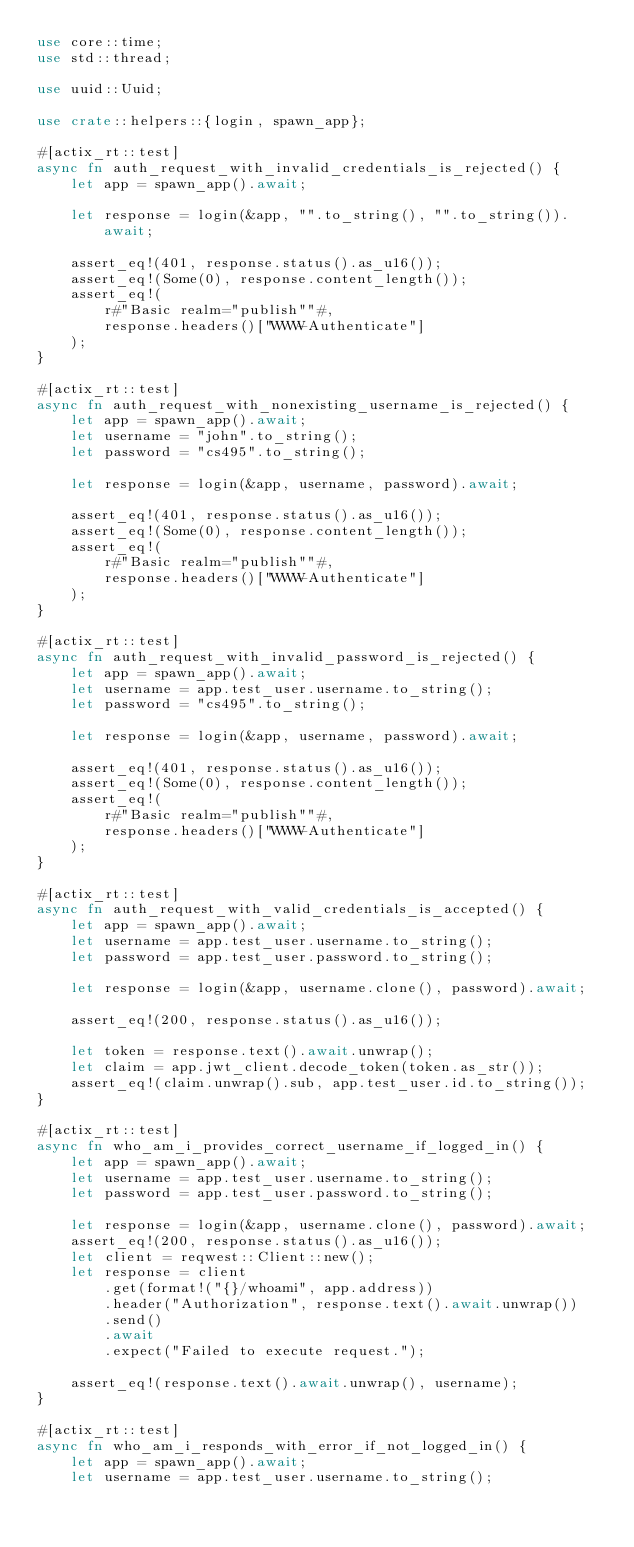Convert code to text. <code><loc_0><loc_0><loc_500><loc_500><_Rust_>use core::time;
use std::thread;

use uuid::Uuid;

use crate::helpers::{login, spawn_app};

#[actix_rt::test]
async fn auth_request_with_invalid_credentials_is_rejected() {
    let app = spawn_app().await;

    let response = login(&app, "".to_string(), "".to_string()).await;

    assert_eq!(401, response.status().as_u16());
    assert_eq!(Some(0), response.content_length());
    assert_eq!(
        r#"Basic realm="publish""#,
        response.headers()["WWW-Authenticate"]
    );
}

#[actix_rt::test]
async fn auth_request_with_nonexisting_username_is_rejected() {
    let app = spawn_app().await;
    let username = "john".to_string();
    let password = "cs495".to_string();

    let response = login(&app, username, password).await;

    assert_eq!(401, response.status().as_u16());
    assert_eq!(Some(0), response.content_length());
    assert_eq!(
        r#"Basic realm="publish""#,
        response.headers()["WWW-Authenticate"]
    );
}

#[actix_rt::test]
async fn auth_request_with_invalid_password_is_rejected() {
    let app = spawn_app().await;
    let username = app.test_user.username.to_string();
    let password = "cs495".to_string();

    let response = login(&app, username, password).await;

    assert_eq!(401, response.status().as_u16());
    assert_eq!(Some(0), response.content_length());
    assert_eq!(
        r#"Basic realm="publish""#,
        response.headers()["WWW-Authenticate"]
    );
}

#[actix_rt::test]
async fn auth_request_with_valid_credentials_is_accepted() {
    let app = spawn_app().await;
    let username = app.test_user.username.to_string();
    let password = app.test_user.password.to_string();

    let response = login(&app, username.clone(), password).await;

    assert_eq!(200, response.status().as_u16());

    let token = response.text().await.unwrap();
    let claim = app.jwt_client.decode_token(token.as_str());
    assert_eq!(claim.unwrap().sub, app.test_user.id.to_string());
}

#[actix_rt::test]
async fn who_am_i_provides_correct_username_if_logged_in() {
    let app = spawn_app().await;
    let username = app.test_user.username.to_string();
    let password = app.test_user.password.to_string();

    let response = login(&app, username.clone(), password).await;
    assert_eq!(200, response.status().as_u16());
    let client = reqwest::Client::new();
    let response = client
        .get(format!("{}/whoami", app.address))
        .header("Authorization", response.text().await.unwrap())
        .send()
        .await
        .expect("Failed to execute request.");

    assert_eq!(response.text().await.unwrap(), username);
}

#[actix_rt::test]
async fn who_am_i_responds_with_error_if_not_logged_in() {
    let app = spawn_app().await;
    let username = app.test_user.username.to_string();</code> 